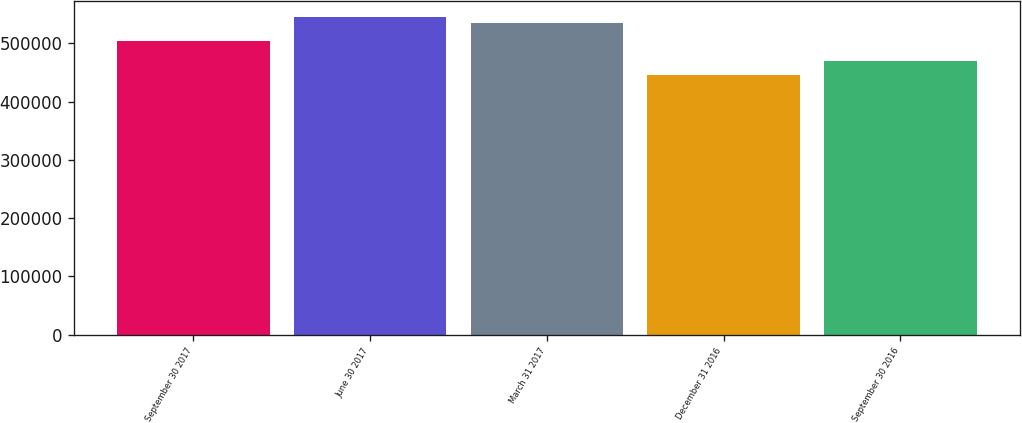Convert chart to OTSL. <chart><loc_0><loc_0><loc_500><loc_500><bar_chart><fcel>September 30 2017<fcel>June 30 2017<fcel>March 31 2017<fcel>December 31 2016<fcel>September 30 2016<nl><fcel>503462<fcel>544742<fcel>535224<fcel>445646<fcel>470222<nl></chart> 